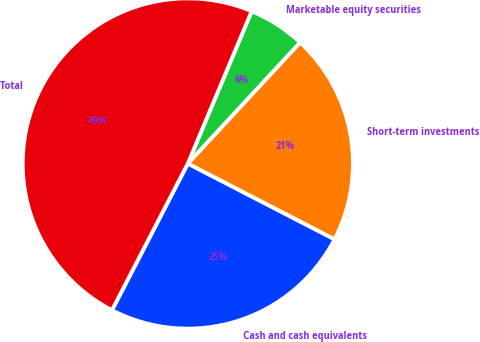Convert chart. <chart><loc_0><loc_0><loc_500><loc_500><pie_chart><fcel>Cash and cash equivalents<fcel>Short-term investments<fcel>Marketable equity securities<fcel>Total<nl><fcel>25.01%<fcel>20.69%<fcel>5.58%<fcel>48.72%<nl></chart> 